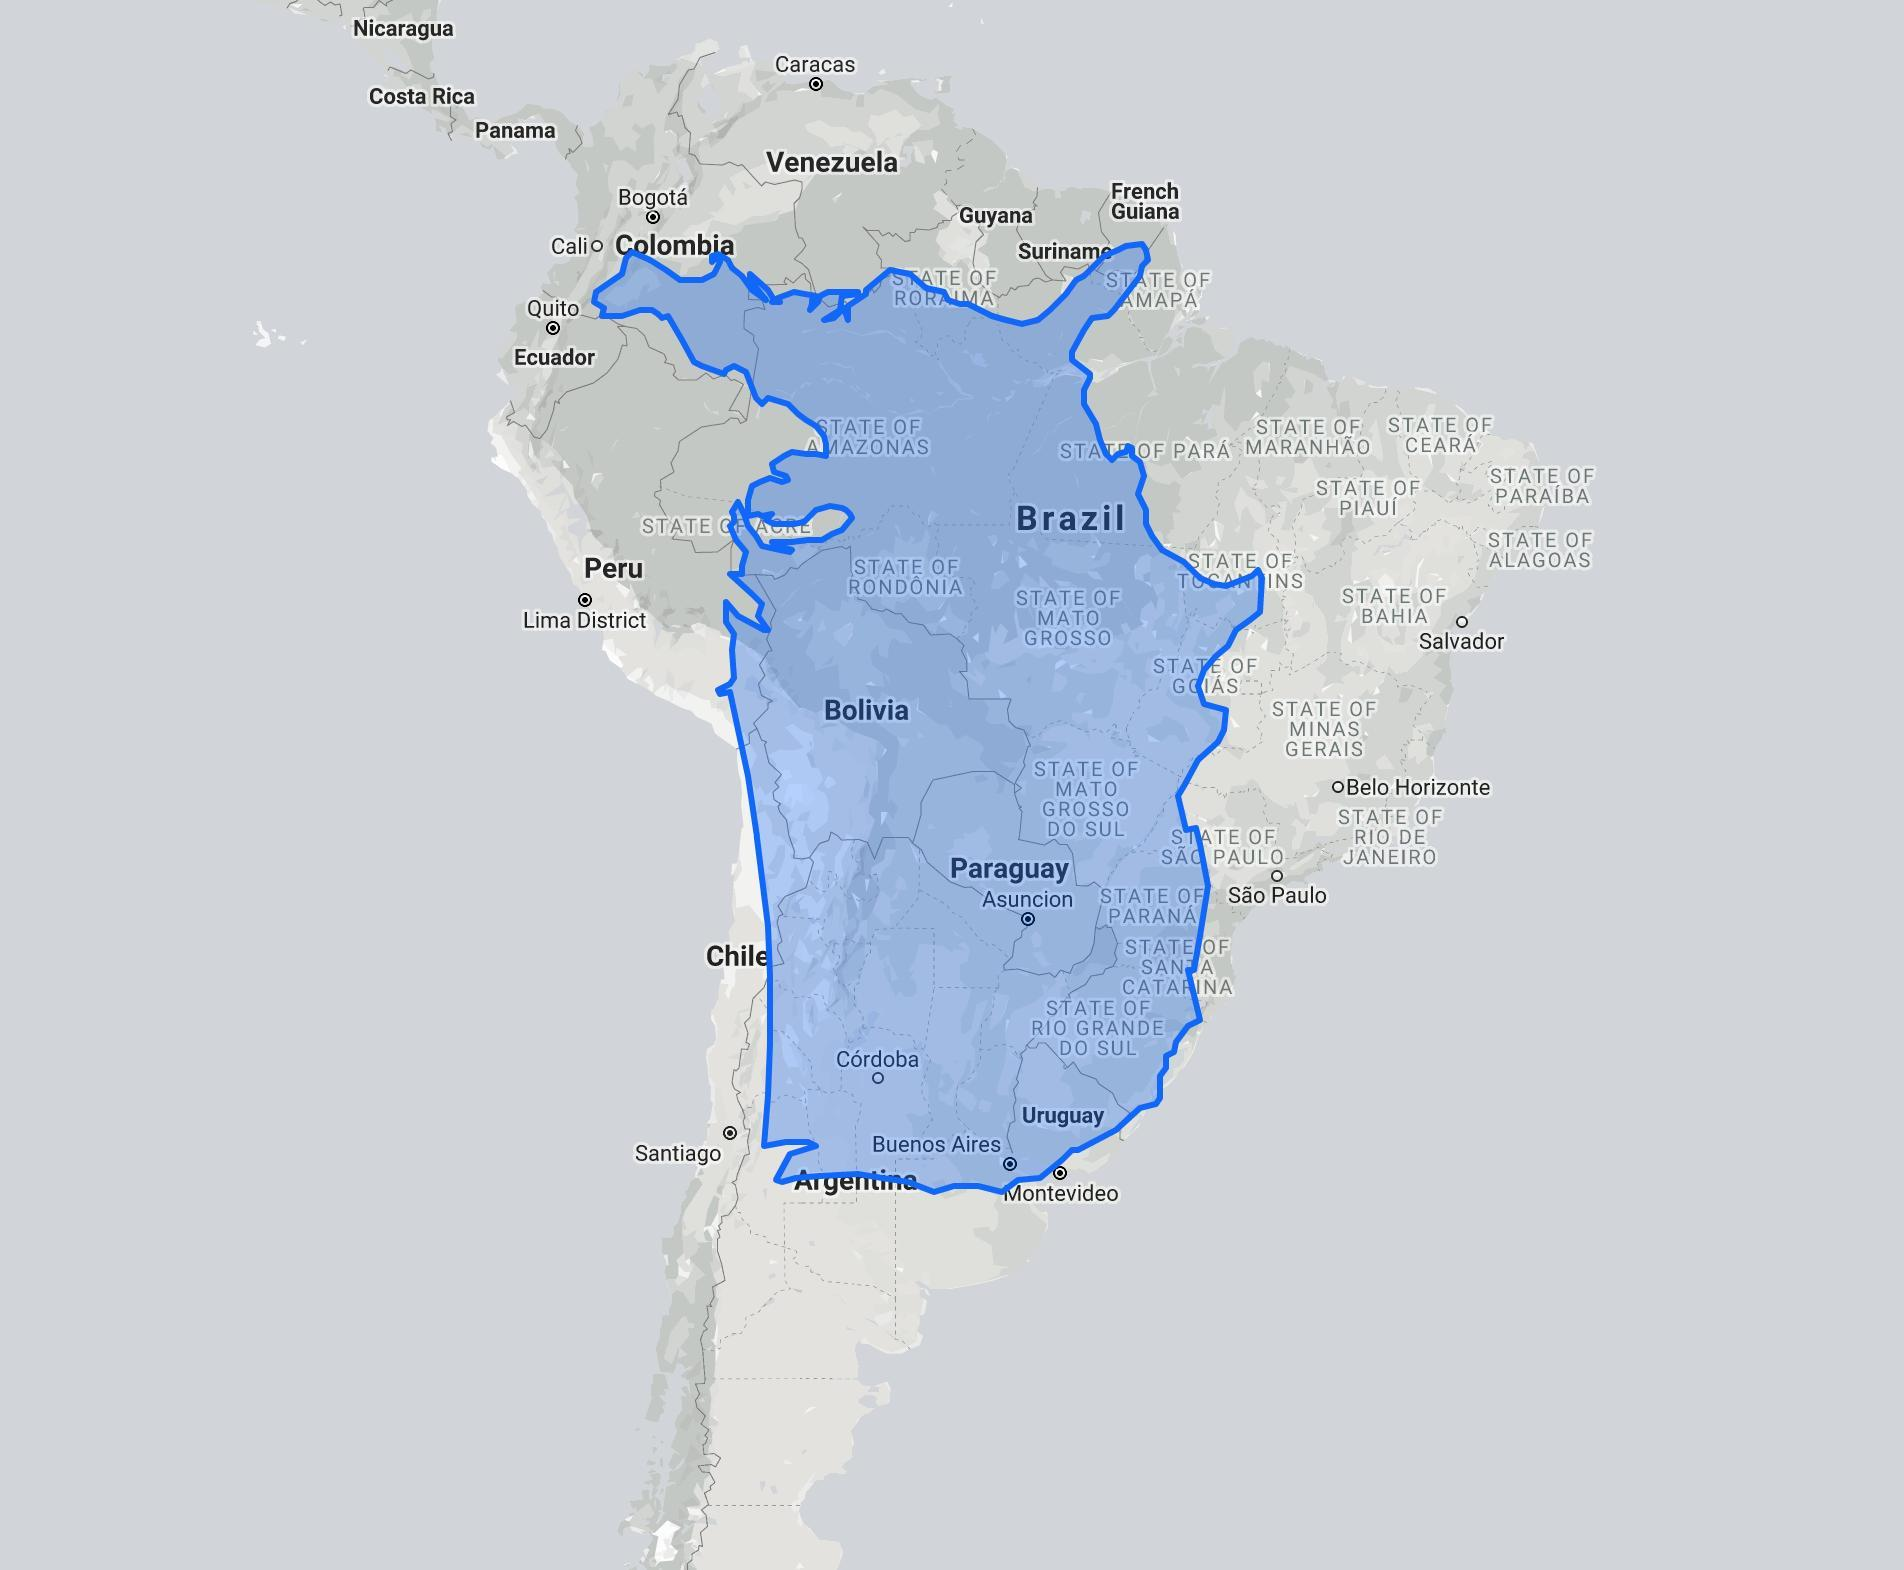What is the name of the country in big letters inside the blue region in map?
Answer the question with a short phrase. Brazil 